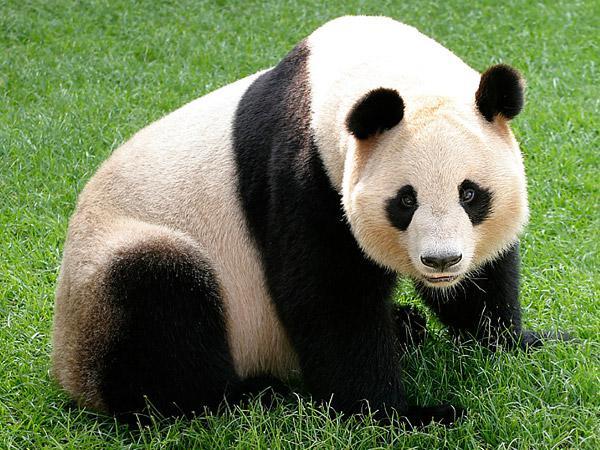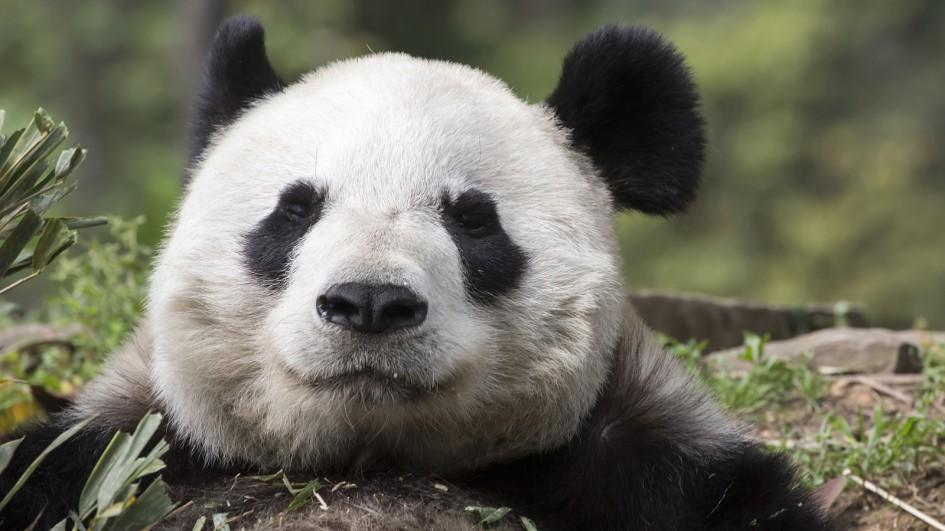The first image is the image on the left, the second image is the image on the right. For the images shown, is this caption "In one of the images, a panda has food in its mouth" true? Answer yes or no. No. The first image is the image on the left, the second image is the image on the right. Given the left and right images, does the statement "A panda is eating in one of the images." hold true? Answer yes or no. No. The first image is the image on the left, the second image is the image on the right. Analyze the images presented: Is the assertion "In one of the images, a panda is eating something" valid? Answer yes or no. No. 